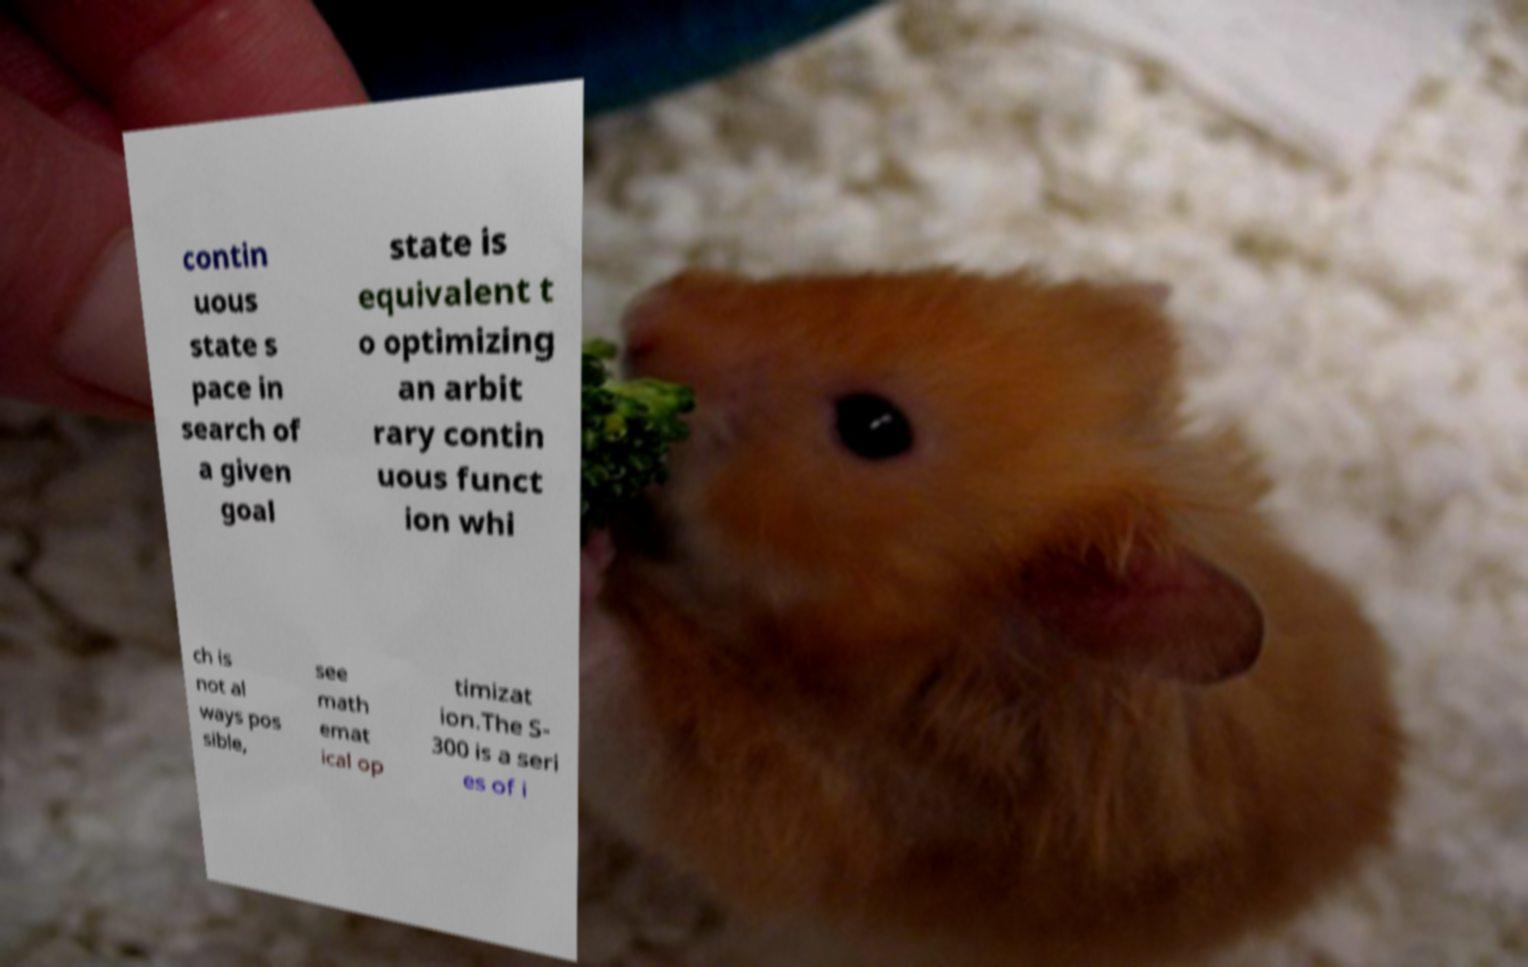Could you assist in decoding the text presented in this image and type it out clearly? contin uous state s pace in search of a given goal state is equivalent t o optimizing an arbit rary contin uous funct ion whi ch is not al ways pos sible, see math emat ical op timizat ion.The S- 300 is a seri es of i 